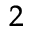Convert formula to latex. <formula><loc_0><loc_0><loc_500><loc_500>^ { 2 }</formula> 